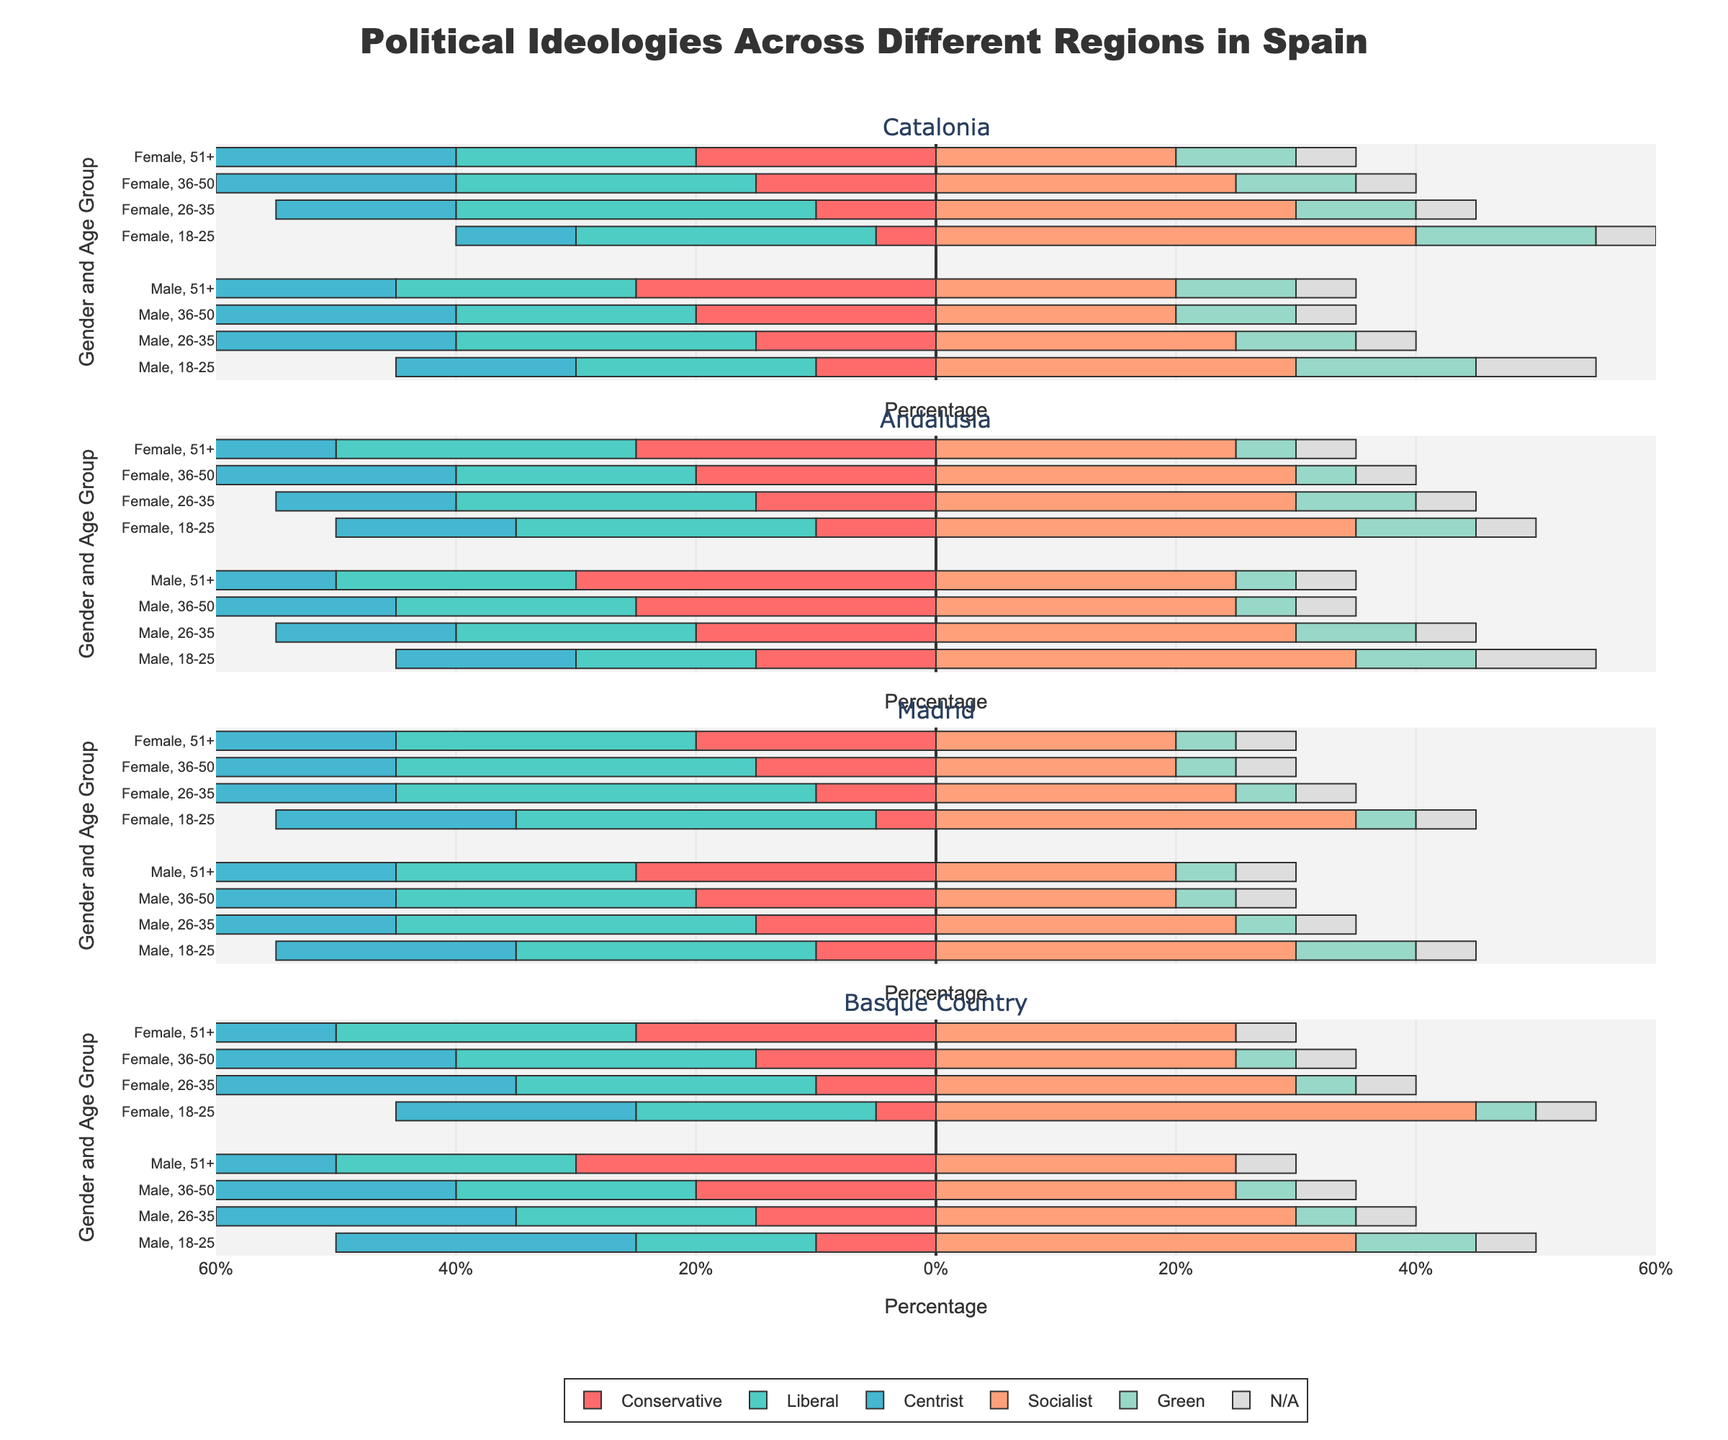Which gender in Catalonia has the highest percentage of Socialist ideology among the 18-25 age group? Look at Catalonia's 18-25 age group and compare the percentages for males and females under the Socialist ideology. The female group has 40% while the male group has 30%.
Answer: Female Which region has the highest conservative representation for males aged 51+? Compare the Conservative percentages for males aged 51+ across Catalonia, Andalusia, Madrid, and Basque Country. Catalonia has 25%, Andalusia has 30%, Madrid has 25%, and Basque Country has 30%. Both Andalusia and Basque Country have the highest at 30%.
Answer: Andalusia, Basque Country In the Basque Country, what is the total percentage of the N/A category across all age groups for females? Look at the N/A percentages for females in the Basque Country across all age groups and sum them: 5% (18-25) + 5% (26-35) + 5% (36-50) + 5% (51+). The total is 20%.
Answer: 20% What ideology shows the least variation in percentage among different age groups in Madrid for males? Look at the percentage differences for each ideology across different age groups in Madrid for males. Conservative (10%, 15%, 20%, 25%) shows a steady increase by 5%, whereas other ideologies vary.
Answer: Conservative For females aged 36-50 in Andalusia, which ideology is the second most popular? Examine percentages of each ideology for females aged 36-50 in Andalusia. The highest is Socialist at 30%, and the second highest is a tie between Conservative and Centrist, both at 20%.
Answer: Conservative, Centrist In which region does the Socialist ideology for males aged 26-35 have the lowest representation? Look at the percentages for Socialist ideology among males aged 26-35 in Catalonia, Andalusia, Madrid, and Basque Country. The percentages are 25%, 30%, 25%, and 30% respectively. The lowest is in Catalonia and Madrid.
Answer: Catalonia, Madrid How does the Green ideology representation differ between females aged 18-25 in Catalonia and Madrid? Examine the Green ideology percentages for females aged 18-25 in Catalonia and Madrid. Catalonia shows 15%, while Madrid shows 5%. The difference is 10%.
Answer: 10% What is the average percentage of Liberal ideology across all age groups for males in the Basque Country? Sum the Liberal percentages for males in the Basque Country across all age groups (18-25, 26-35, 36-50, 51+): 15% + 20% + 20% + 20% = 75%. Divide by 4 age groups: 75% / 4 = 18.75%.
Answer: 18.75% Which age group in Andalusia has the highest percentage of the Centrist ideology for females? Compare the Centrist ideology percentages among different age groups for females in Andalusia. Both the 36-50 and 51+ age groups have the highest at 20%.
Answer: 36-50, 51+ In Madrid, for females aged 26-35, between which two ideologies is the difference the largest, and what is the value? For females aged 26-35 in Madrid, examine the percentage differences among ideologies. The largest difference is between Liberal (35%) and Conservative (10%), which is 25%.
Answer: Conservative and Liberal, 25% 